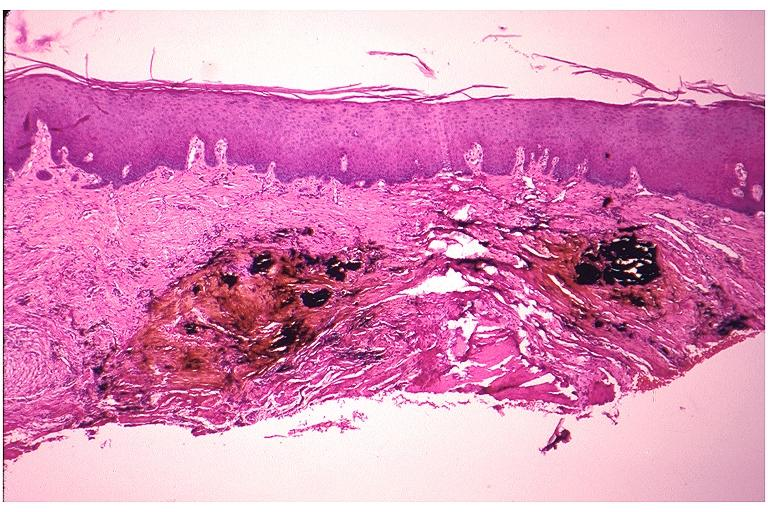where is this?
Answer the question using a single word or phrase. Oral 